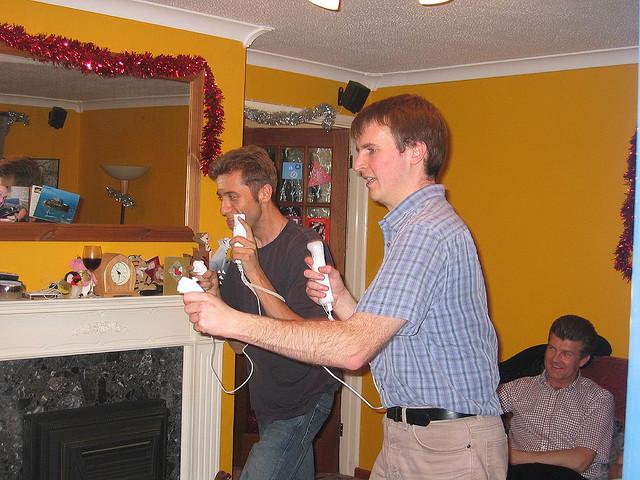Are these two brothers?
Give a very brief answer. Yes. Are they playing a video game?
Give a very brief answer. Yes. Who is seated?
Answer briefly. Man. 